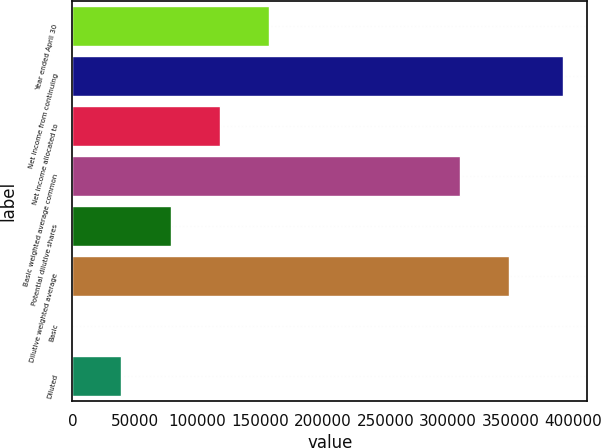Convert chart to OTSL. <chart><loc_0><loc_0><loc_500><loc_500><bar_chart><fcel>Year ended April 30<fcel>Net income from continuing<fcel>Net income allocated to<fcel>Basic weighted average common<fcel>Potential dilutive shares<fcel>Dilutive weighted average<fcel>Basic<fcel>Diluted<nl><fcel>157020<fcel>391540<fcel>117765<fcel>309230<fcel>78510.4<fcel>348485<fcel>1.27<fcel>39255.8<nl></chart> 